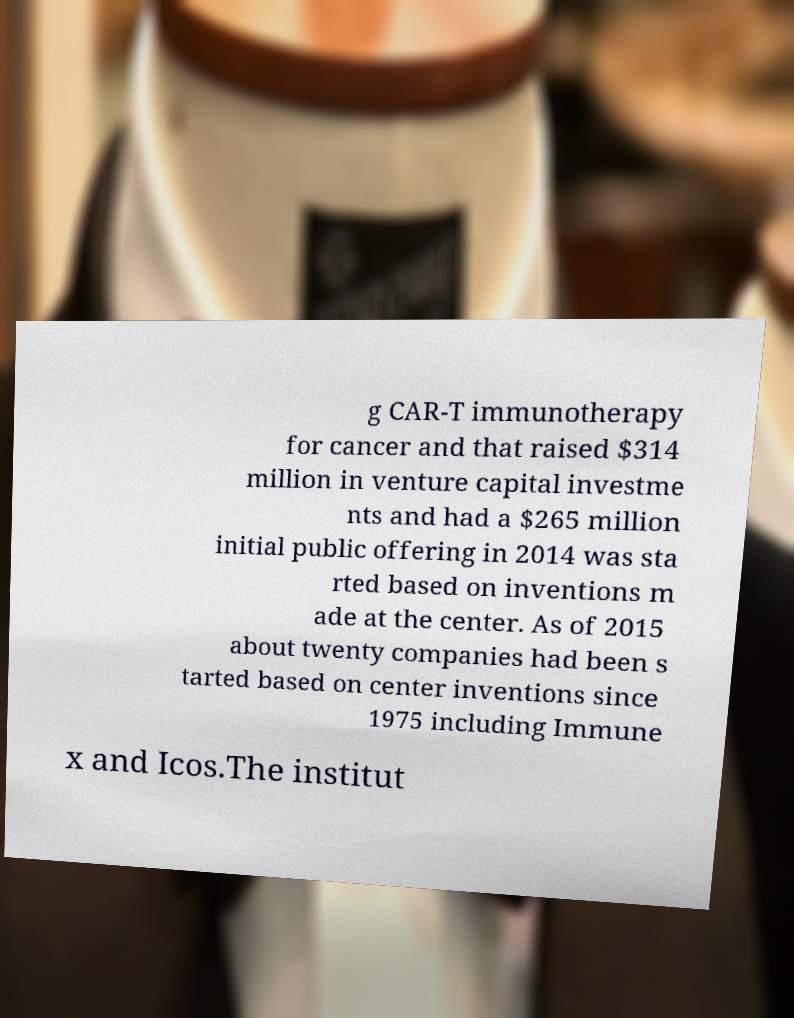For documentation purposes, I need the text within this image transcribed. Could you provide that? g CAR-T immunotherapy for cancer and that raised $314 million in venture capital investme nts and had a $265 million initial public offering in 2014 was sta rted based on inventions m ade at the center. As of 2015 about twenty companies had been s tarted based on center inventions since 1975 including Immune x and Icos.The institut 